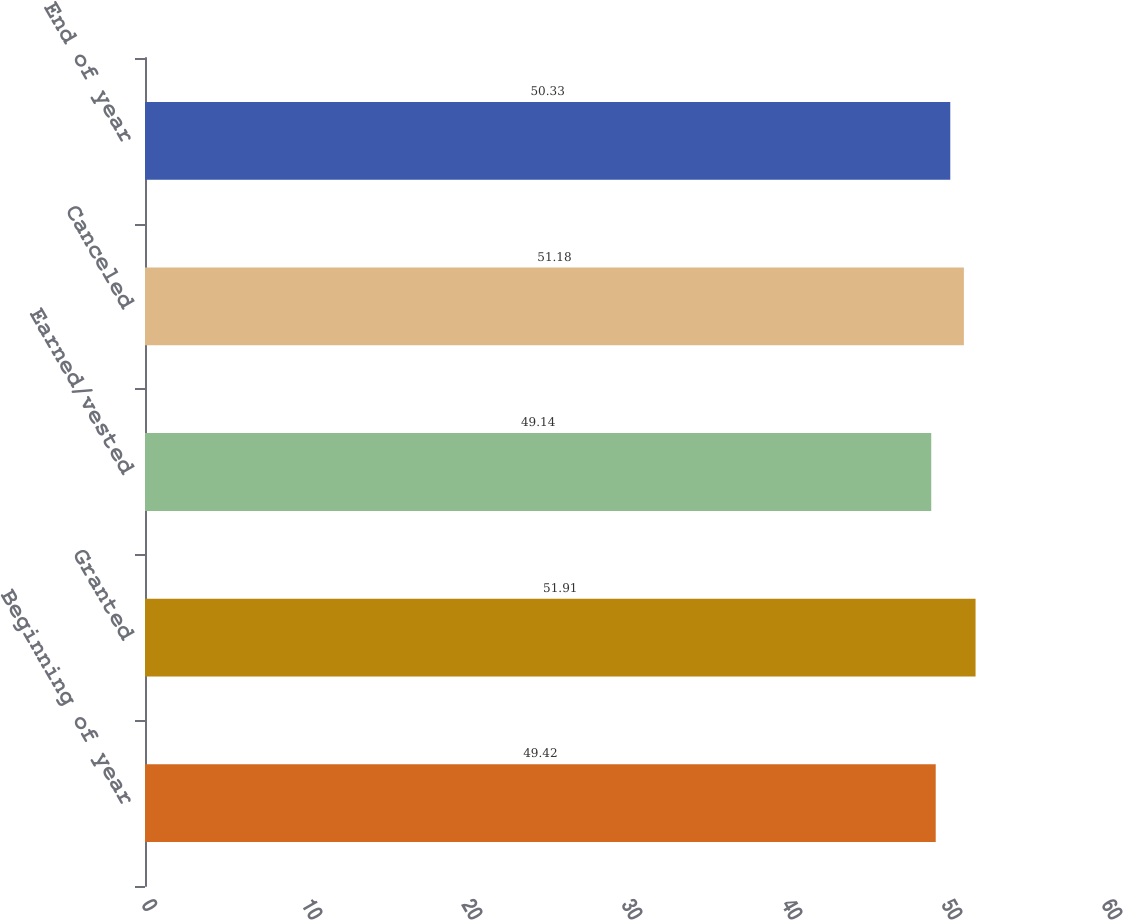<chart> <loc_0><loc_0><loc_500><loc_500><bar_chart><fcel>Beginning of year<fcel>Granted<fcel>Earned/vested<fcel>Canceled<fcel>End of year<nl><fcel>49.42<fcel>51.91<fcel>49.14<fcel>51.18<fcel>50.33<nl></chart> 